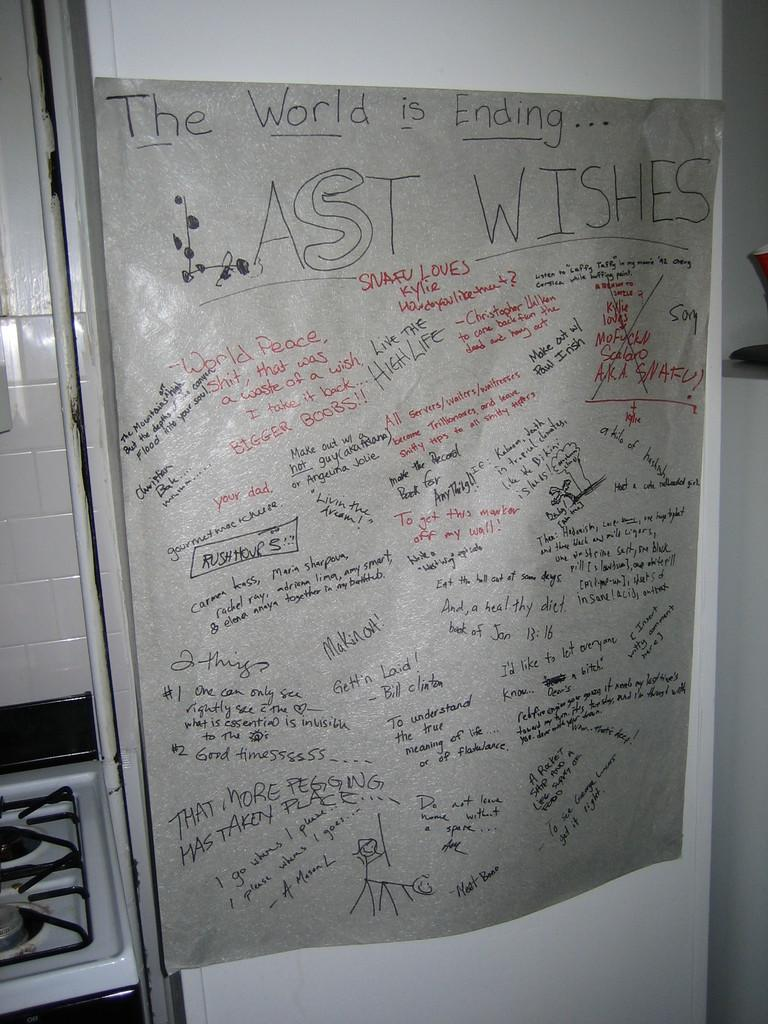What color is the background of the image? The background of the image is white. What is present on the paper in the image? There is a paper with writing on it in the image. What can be seen on the left side of the image? There is a stove on the left side of the image. How many dogs are playing a game on the stove in the image? There are no dogs or game present in the image; it features a white background, a paper with writing, and a stove. 